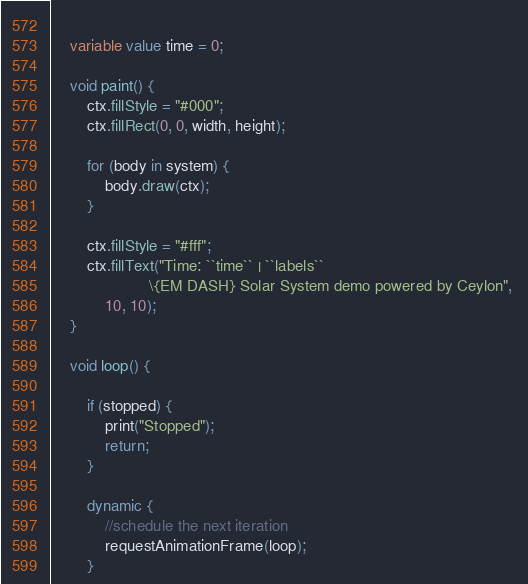<code> <loc_0><loc_0><loc_500><loc_500><_Ceylon_>	
	variable value time = 0;
	
	void paint() {
		ctx.fillStyle = "#000";
		ctx.fillRect(0, 0, width, height);
		
		for (body in system) {
			body.draw(ctx);
		}
		
		ctx.fillStyle = "#fff";
		ctx.fillText("Time: ``time`` | ``labels`` 
		              \{EM DASH} Solar System demo powered by Ceylon", 
			10, 10);
	}
	
	void loop() {
		
		if (stopped) {
			print("Stopped");
			return;
		}
		
		dynamic {
			//schedule the next iteration
			requestAnimationFrame(loop);
		}</code> 